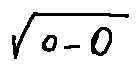Convert formula to latex. <formula><loc_0><loc_0><loc_500><loc_500>\sqrt { o - 0 }</formula> 